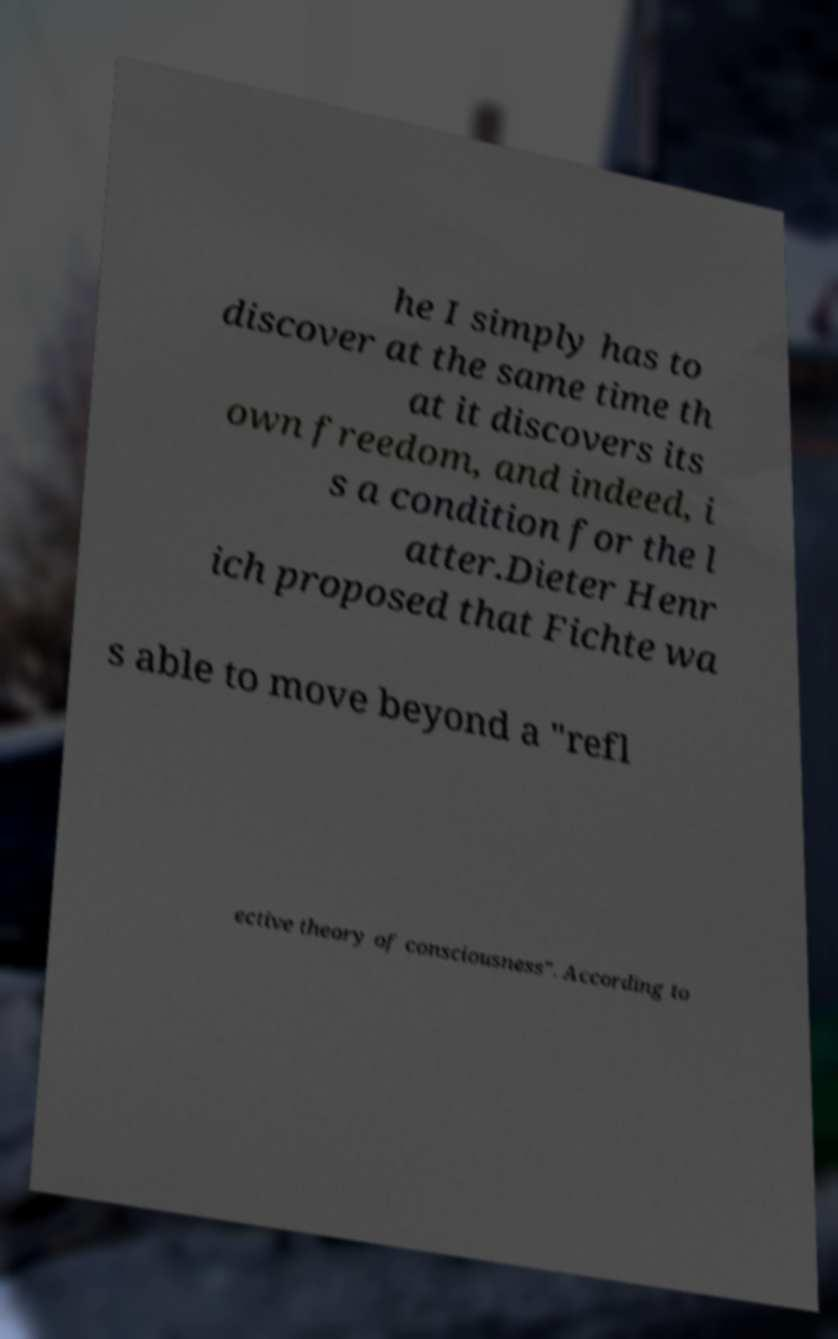Could you extract and type out the text from this image? he I simply has to discover at the same time th at it discovers its own freedom, and indeed, i s a condition for the l atter.Dieter Henr ich proposed that Fichte wa s able to move beyond a "refl ective theory of consciousness". According to 